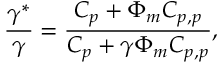<formula> <loc_0><loc_0><loc_500><loc_500>\frac { \gamma ^ { * } } { \gamma } = \frac { C _ { p } + \Phi _ { m } C _ { p , p } } { C _ { p } + \gamma \Phi _ { m } C _ { p , p } } ,</formula> 